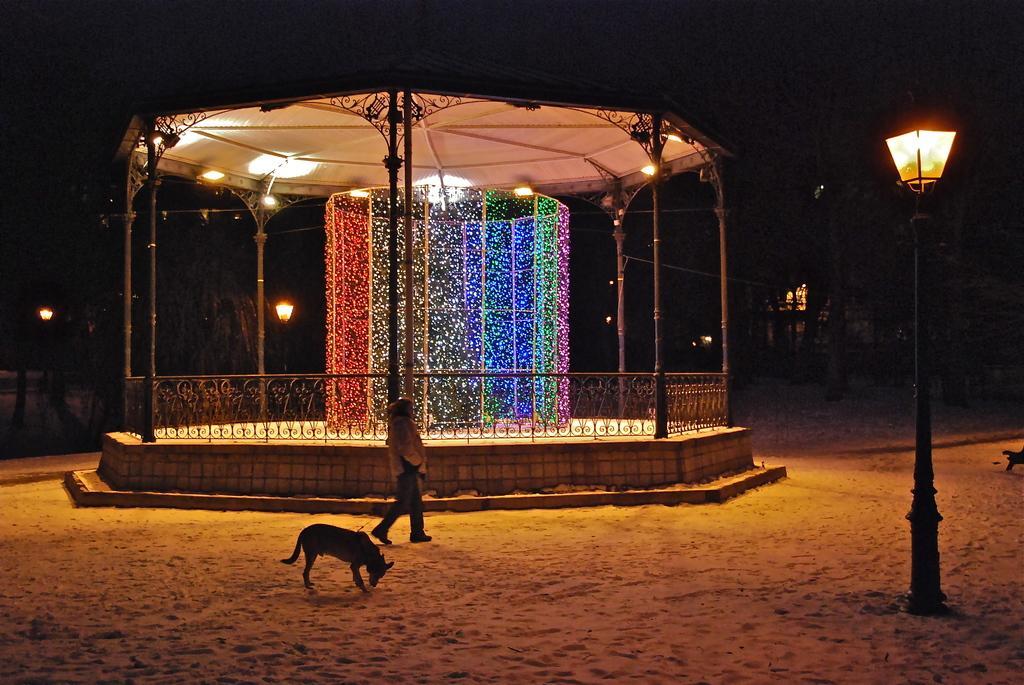Describe this image in one or two sentences. In this image we can see a person walking. There is a dog. There is a shed with lights. There are light poles. At the bottom of the image there is sand. 